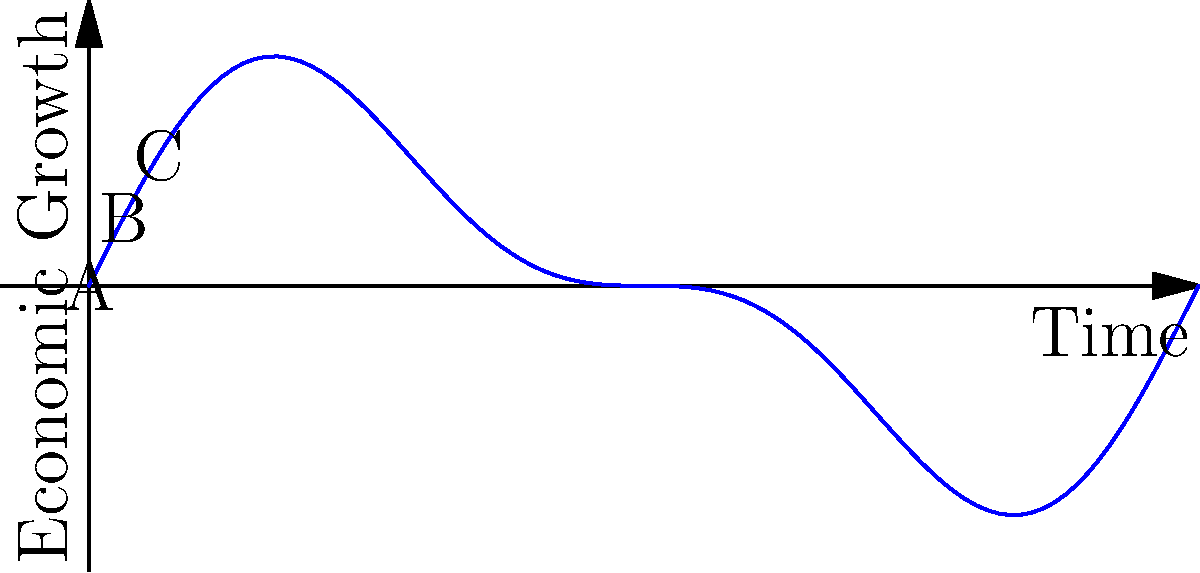Consider the cyclical graph representing economic growth over time. If we apply a rotation of $\pi$ radians around the origin, which point(s) would map onto themselves, demonstrating rotational symmetry in the economic cycle? To determine which point(s) demonstrate rotational symmetry under a $\pi$ radian rotation, we need to follow these steps:

1. Understand rotational symmetry: A figure has rotational symmetry if it can be rotated about its center by a certain angle and still look the same.

2. Analyze the $\pi$ radian rotation: This is equivalent to a 180-degree rotation around the origin.

3. Examine each point:
   a) Point A (0, f(0)): When rotated by $\pi$ radians, it maps to (0, -f(0)), which is not the same point.
   b) Point B ($\pi$, f($\pi$)): When rotated by $\pi$ radians, it maps to (-$\pi$, -f($\pi$)), which is not on the original curve.
   c) Point C (2$\pi$, f(2$\pi$)): When rotated by $\pi$ radians, it maps to ($\pi$, -f(2$\pi$)), which is not the same point.

4. Consider the origin (0,0): This point is not labeled but is implicit in the graph. When rotated by any angle, including $\pi$ radians, it always maps onto itself.

5. Economic interpretation: The origin representing zero growth at the midpoint of the cycle is the only point that remains invariant under this rotation, suggesting a symmetry in the positive and negative phases of the economic cycle around this point.
Answer: The origin (0,0) 